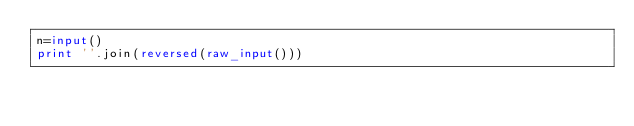Convert code to text. <code><loc_0><loc_0><loc_500><loc_500><_Python_>n=input()
print ''.join(reversed(raw_input()))</code> 